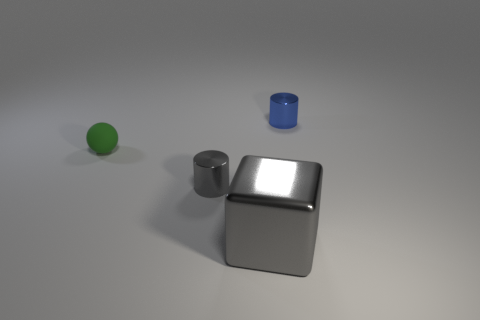Are there any other things that have the same material as the large gray cube?
Offer a very short reply. Yes. There is a gray object that is on the right side of the tiny metallic thing on the left side of the big metallic thing; what shape is it?
Your answer should be compact. Cube. What number of tiny objects are metal cylinders or blue metallic cylinders?
Offer a terse response. 2. How many other tiny green rubber things are the same shape as the matte object?
Keep it short and to the point. 0. There is a small blue shiny object; is it the same shape as the gray metallic object that is behind the large metal cube?
Provide a succinct answer. Yes. What number of gray shiny cubes are behind the sphere?
Your answer should be very brief. 0. Is there a metallic cylinder of the same size as the green matte sphere?
Offer a terse response. Yes. Do the shiny object that is behind the gray metal cylinder and the large gray object have the same shape?
Your answer should be very brief. No. What color is the large thing?
Your answer should be very brief. Gray. Is there a tiny metallic cylinder?
Make the answer very short. Yes. 